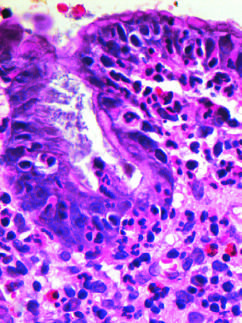what are prominent?
Answer the question using a single word or phrase. Intraepithelial and lamina propria neutrophils 